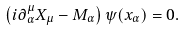<formula> <loc_0><loc_0><loc_500><loc_500>\left ( i \partial _ { \alpha } ^ { \mu } X _ { \mu } - M _ { \alpha } \right ) \psi ( { x _ { \alpha } } ) = 0 .</formula> 